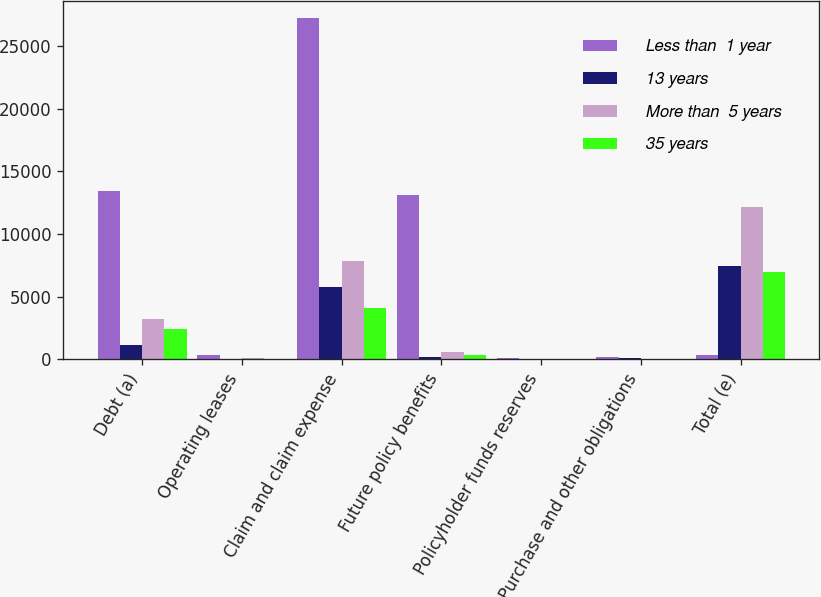Convert chart to OTSL. <chart><loc_0><loc_0><loc_500><loc_500><stacked_bar_chart><ecel><fcel>Debt (a)<fcel>Operating leases<fcel>Claim and claim expense<fcel>Future policy benefits<fcel>Policyholder funds reserves<fcel>Purchase and other obligations<fcel>Total (e)<nl><fcel>Less than  1 year<fcel>13442<fcel>321<fcel>27238<fcel>13101<fcel>137<fcel>181<fcel>321<nl><fcel>13 years<fcel>1156<fcel>58<fcel>5769<fcel>173<fcel>23<fcel>107<fcel>7441<nl><fcel>More than  5 years<fcel>3195<fcel>104<fcel>7850<fcel>602<fcel>13<fcel>33<fcel>12157<nl><fcel>35 years<fcel>2401<fcel>66<fcel>4126<fcel>320<fcel>5<fcel>27<fcel>6945<nl></chart> 